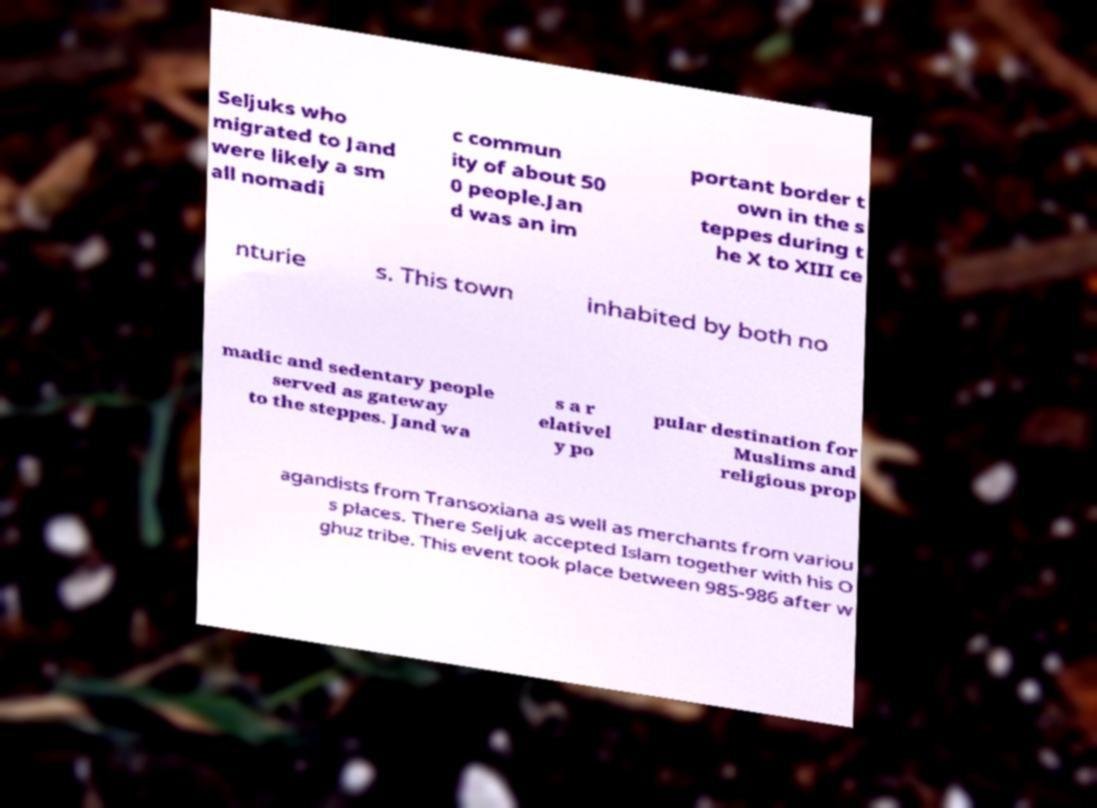I need the written content from this picture converted into text. Can you do that? Seljuks who migrated to Jand were likely a sm all nomadi c commun ity of about 50 0 people.Jan d was an im portant border t own in the s teppes during t he X to XIII ce nturie s. This town inhabited by both no madic and sedentary people served as gateway to the steppes. Jand wa s a r elativel y po pular destination for Muslims and religious prop agandists from Transoxiana as well as merchants from variou s places. There Seljuk accepted Islam together with his O ghuz tribe. This event took place between 985-986 after w 